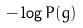Convert formula to latex. <formula><loc_0><loc_0><loc_500><loc_500>- \log P ( g )</formula> 